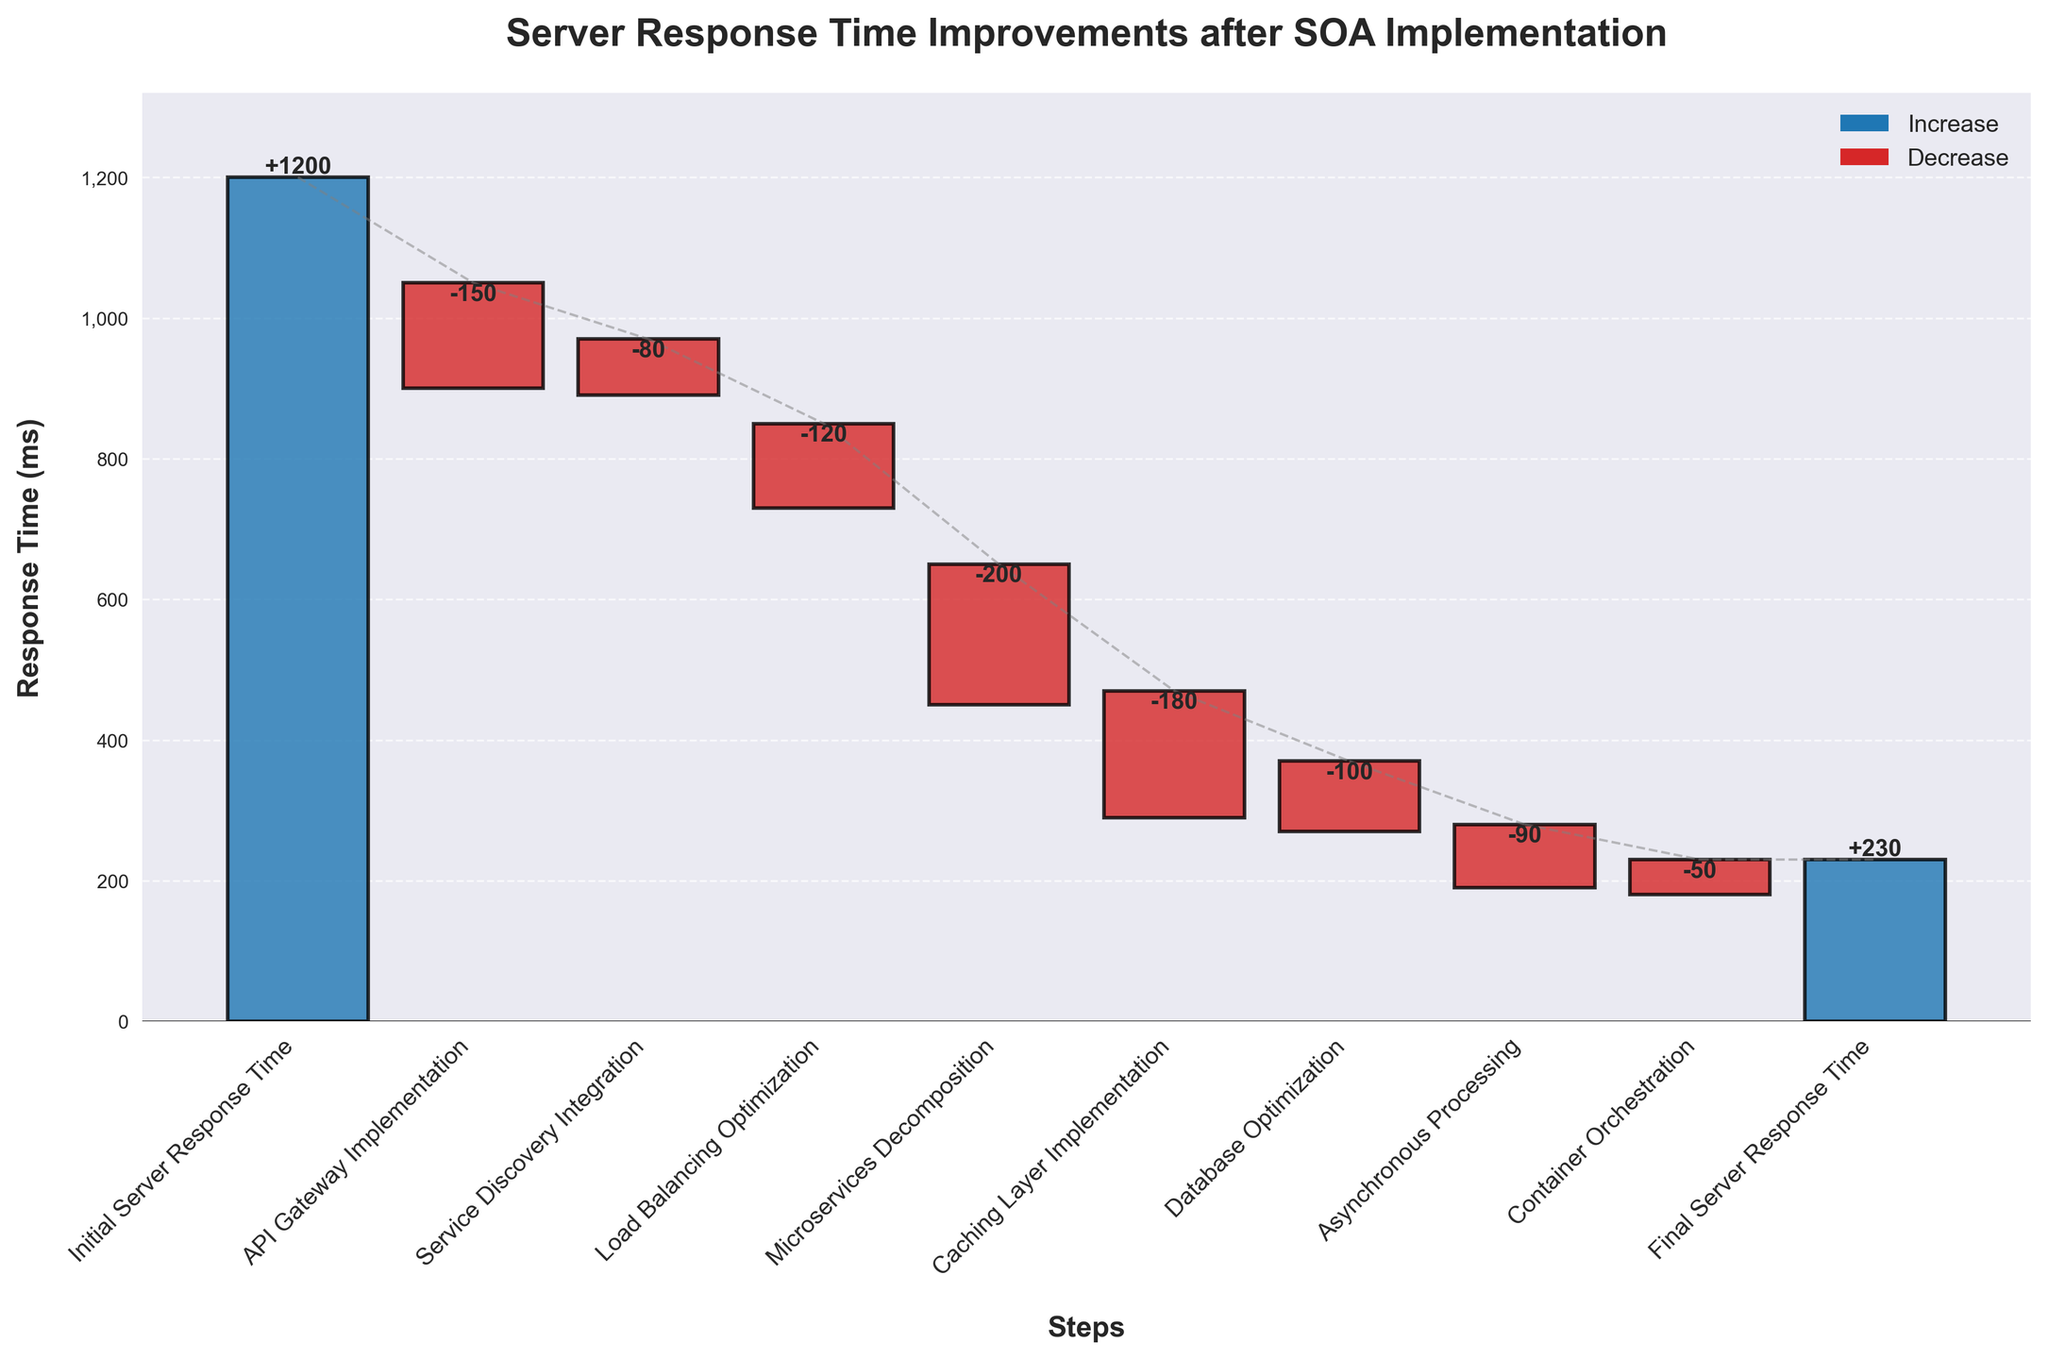What is the initial server response time? The initial server response time is shown as the first value in the "Running Total (ms)" column, representing the starting point before any improvements.
Answer: 1200 ms What is the title of the chart? The title of the chart is displayed at the top of the figure in large, bold text.
Answer: Server Response Time Improvements after SOA Implementation How many steps are depicted in the waterfall chart? Count the number of bars in the chart, each representing a step.
Answer: 10 Which step shows the highest decrease in server response time? Look for the step with the largest negative value in the "Time Change (ms)" column.
Answer: Microservices Decomposition What is the final server response time? The final server response time is indicated as the last value in the "Running Total (ms)" column, representing the response time after all improvements.
Answer: 230 ms Which step contributed the least improvement (positive or negative) in response time? Identify the step with the smallest absolute value in the "Time Change (ms)" column.
Answer: Container Orchestration Between which two steps is the largest decrease in server response time observed? Find the steps with the greatest change in the "Running Total (ms)" between any two consecutive steps.
Answer: Microservices Decomposition 